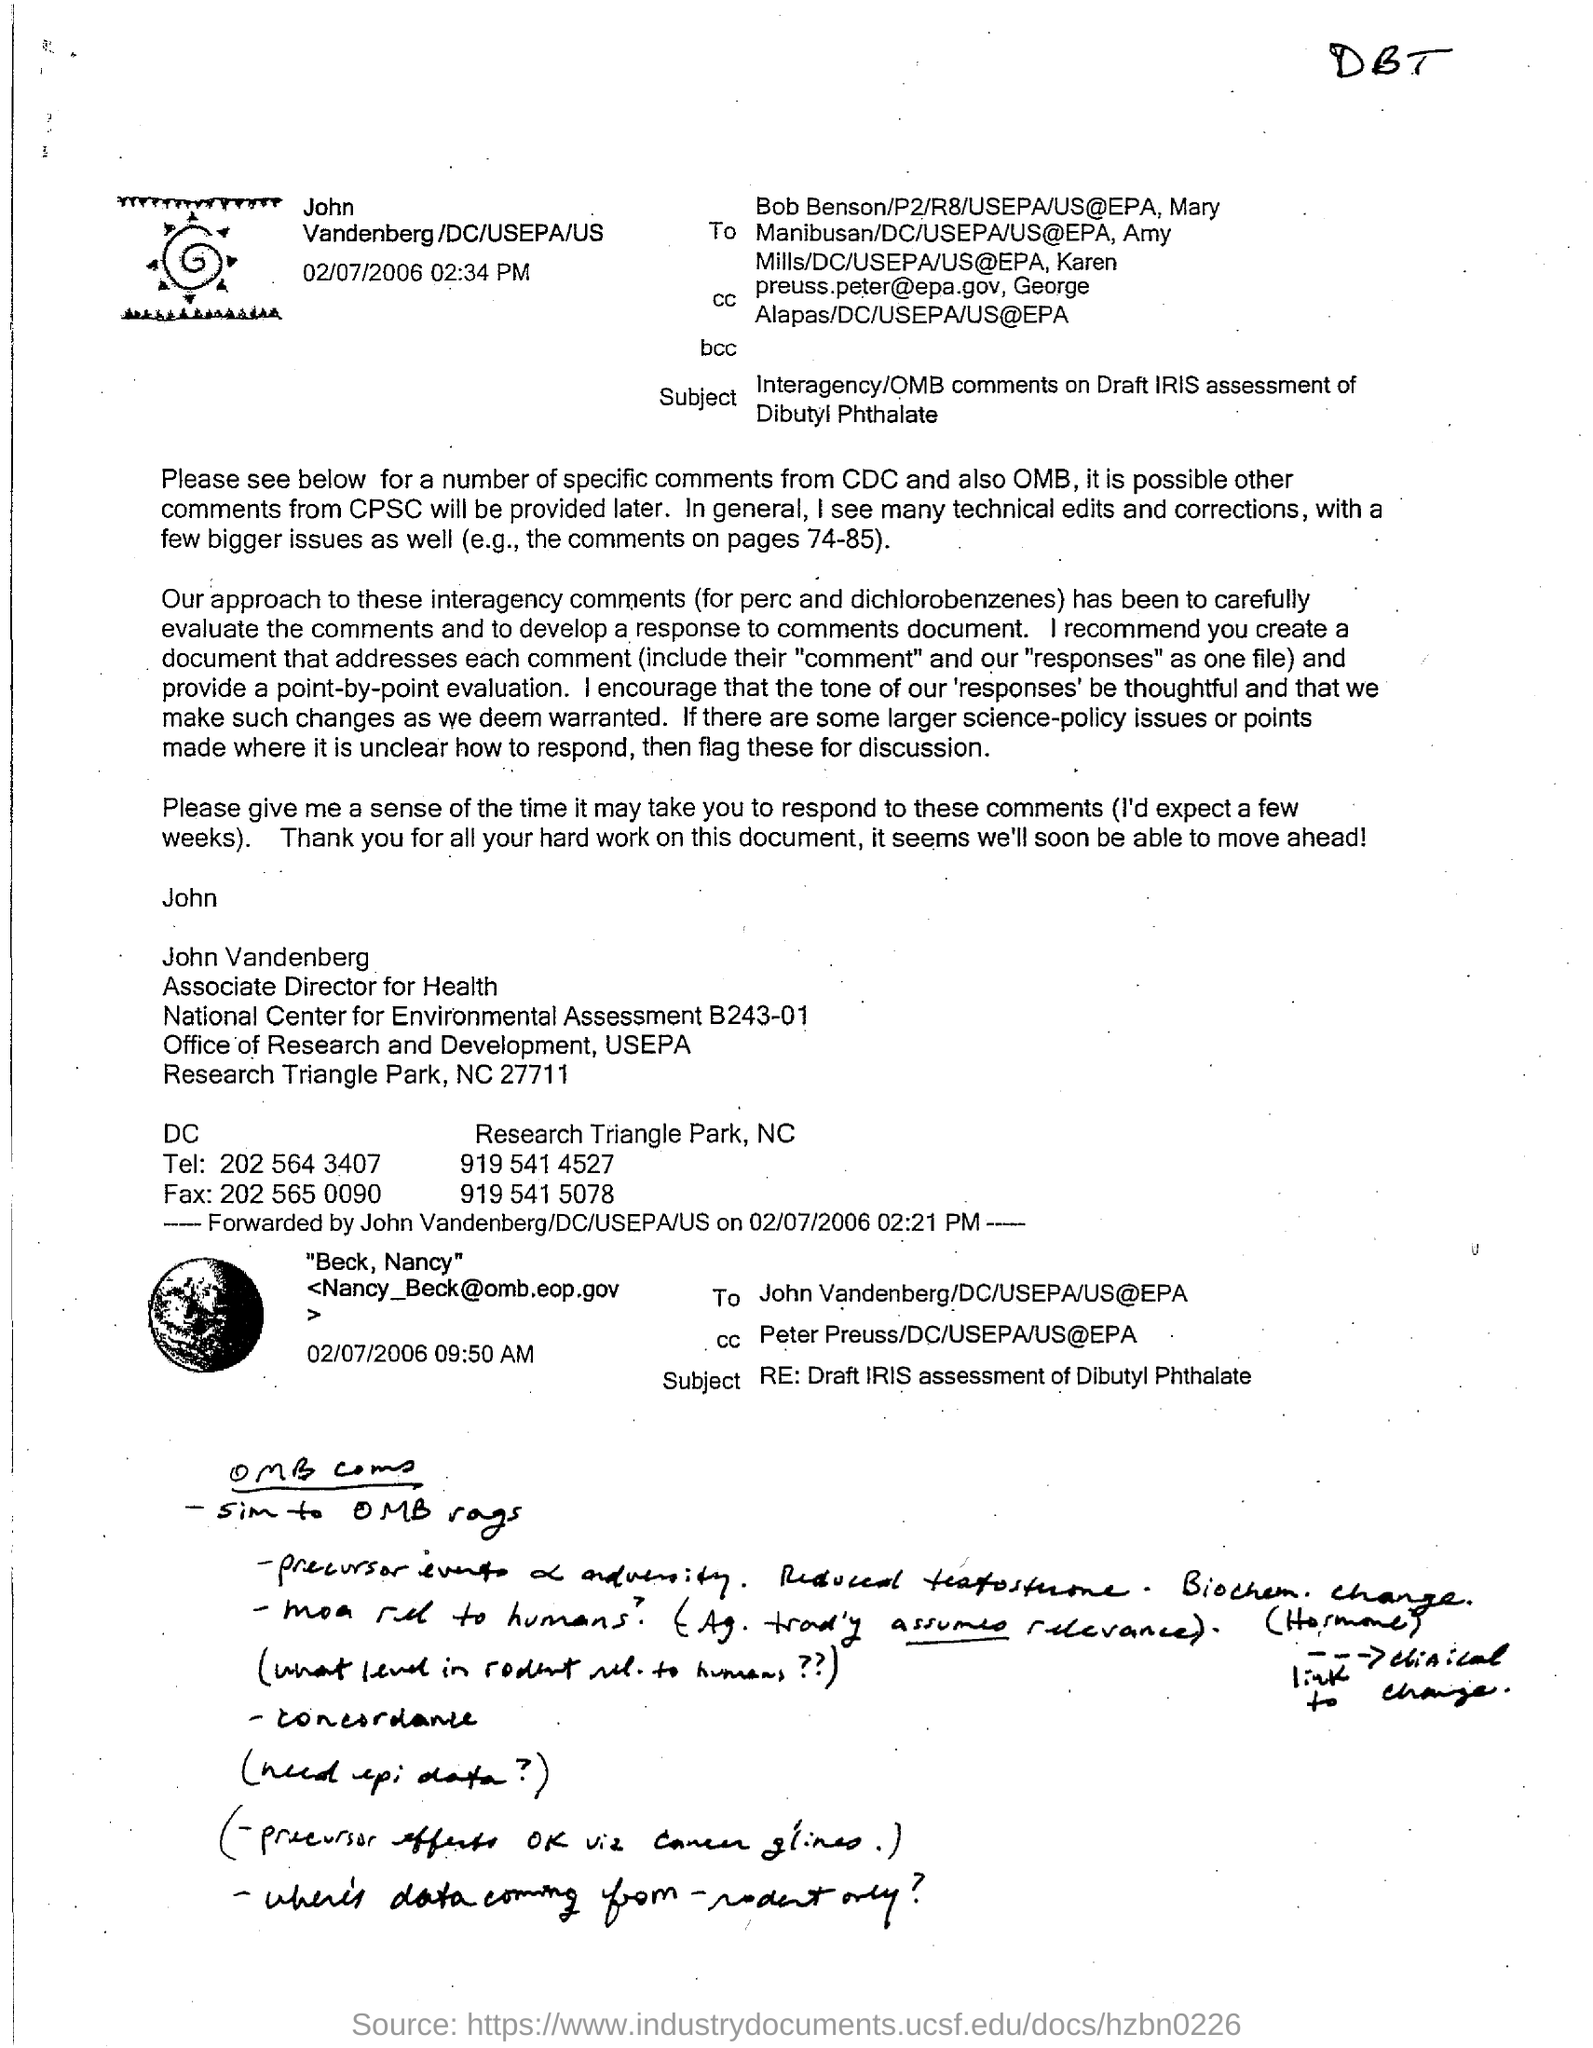Who is the Associate Director for Health?
Your answer should be very brief. John Vandenberg. 